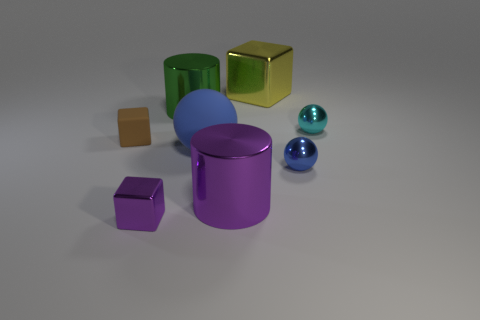There is a metallic block that is to the right of the small block that is in front of the big cylinder in front of the blue metal sphere; what color is it?
Provide a short and direct response. Yellow. Is the material of the ball in front of the big blue matte thing the same as the large blue sphere?
Provide a succinct answer. No. Are there any cubes of the same color as the large matte thing?
Give a very brief answer. No. Are any brown things visible?
Offer a terse response. Yes. There is a metallic cube that is in front of the yellow shiny block; does it have the same size as the green metal cylinder?
Provide a short and direct response. No. Is the number of big metal things less than the number of small brown rubber blocks?
Give a very brief answer. No. What is the shape of the big metal thing in front of the small shiny object that is behind the blue ball on the right side of the big block?
Provide a short and direct response. Cylinder. Is there a large cylinder that has the same material as the purple block?
Provide a short and direct response. Yes. Do the large cylinder in front of the small brown matte cube and the large cylinder behind the cyan metal ball have the same color?
Keep it short and to the point. No. Are there fewer tiny blocks behind the large blue ball than small yellow rubber blocks?
Give a very brief answer. No. 